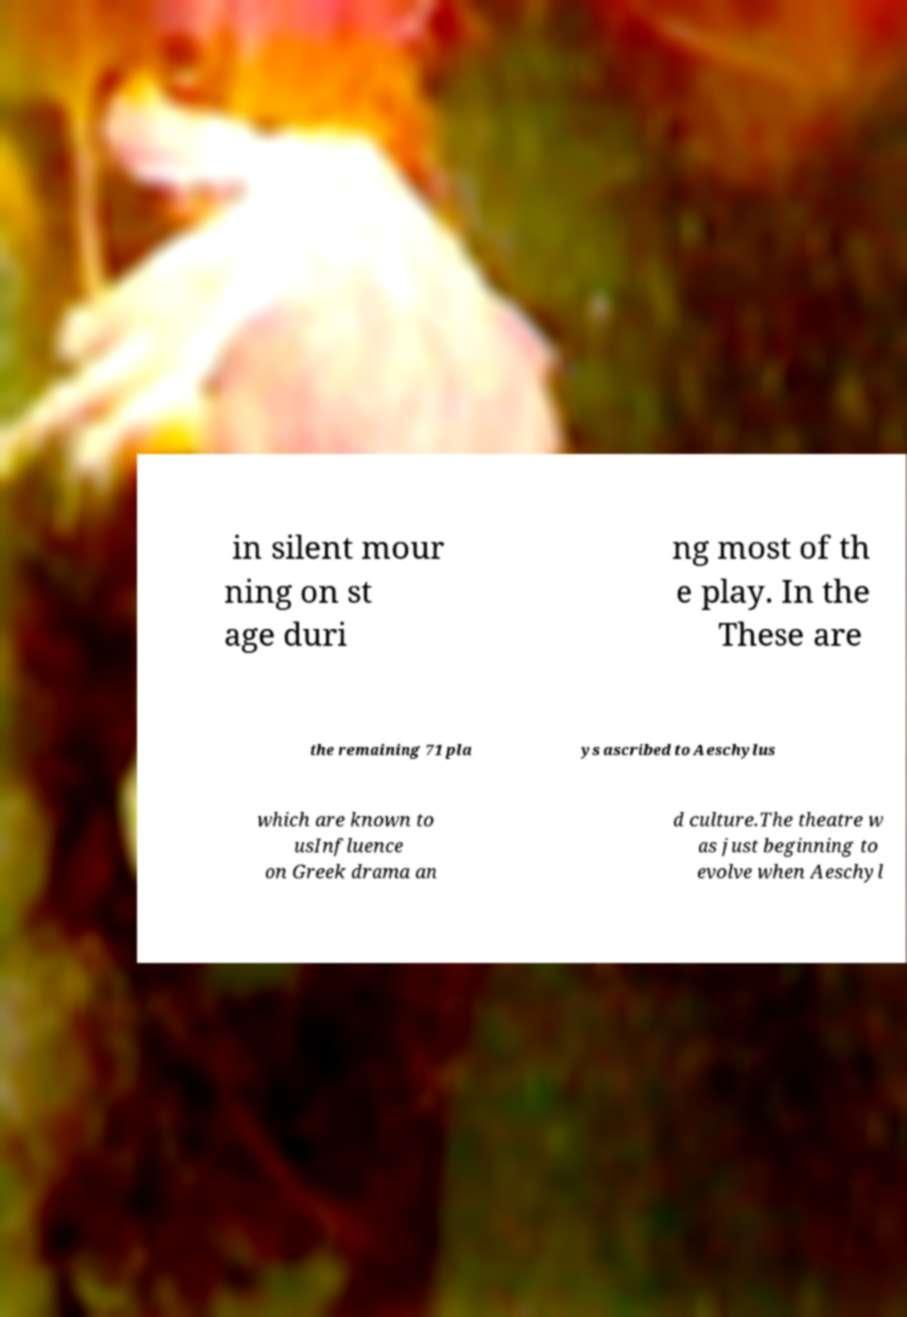Please read and relay the text visible in this image. What does it say? in silent mour ning on st age duri ng most of th e play. In the These are the remaining 71 pla ys ascribed to Aeschylus which are known to usInfluence on Greek drama an d culture.The theatre w as just beginning to evolve when Aeschyl 